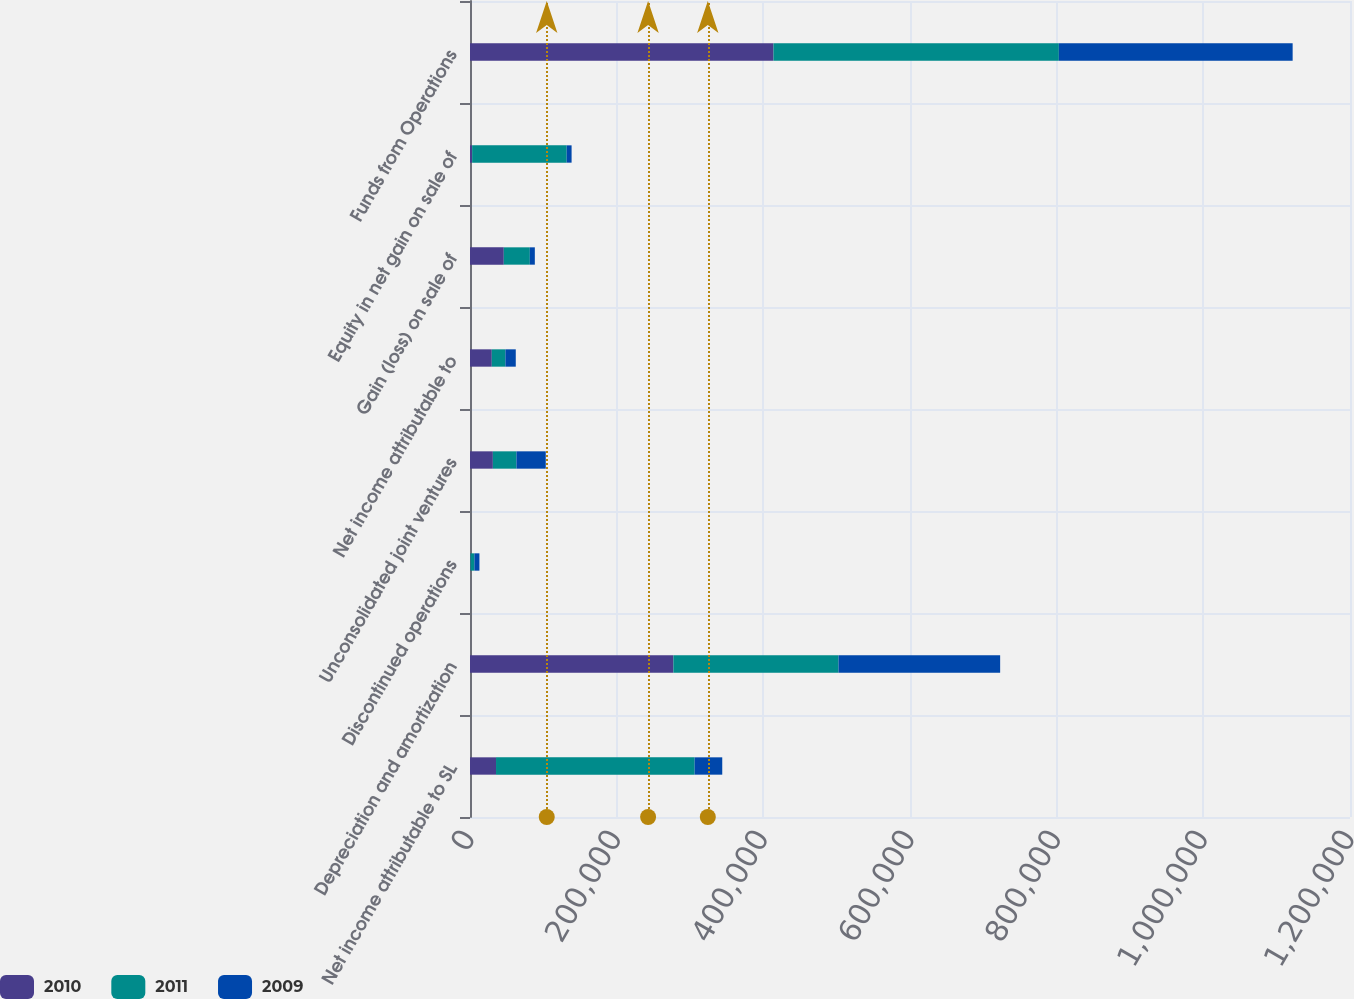<chart> <loc_0><loc_0><loc_500><loc_500><stacked_bar_chart><ecel><fcel>Net income attributable to SL<fcel>Depreciation and amortization<fcel>Discontinued operations<fcel>Unconsolidated joint ventures<fcel>Net income attributable to<fcel>Gain (loss) on sale of<fcel>Equity in net gain on sale of<fcel>Funds from Operations<nl><fcel>2010<fcel>35485<fcel>277345<fcel>676<fcel>31179<fcel>29712<fcel>46085<fcel>2918<fcel>413813<nl><fcel>2011<fcel>270826<fcel>225193<fcel>5326<fcel>32163<fcel>18581<fcel>35485<fcel>128922<fcel>389161<nl><fcel>2009<fcel>37669<fcel>220396<fcel>6857<fcel>39964<fcel>14121<fcel>6841<fcel>6691<fcel>318817<nl></chart> 